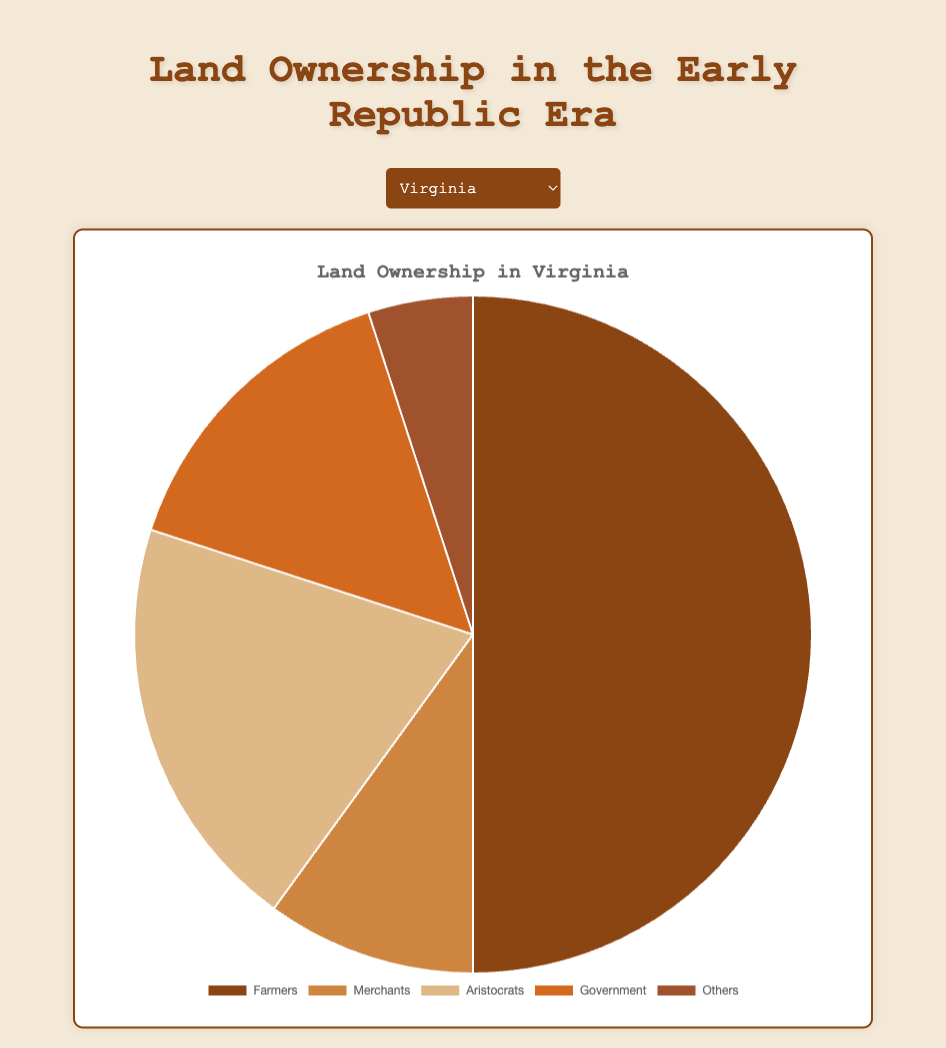What's the most significant category of land ownership in Virginia? Look at the pie chart for Virginia and identify the segment with the largest area. According to the data, Farmers own 50% of the land in Virginia, which is the largest category.
Answer: Farmers Compare the percentage of land owned by Merchants in New York and Pennsylvania. Which state has a higher percentage? Look at the pie charts for New York and Pennsylvania and compare the segments for Merchants. In New York, Merchants own 25% of the land, while in Pennsylvania, they own 20%. Thus, Merchants own a higher percentage of land in New York than in Pennsylvania.
Answer: New York Calculate the total percentage of land owned by Government and Others combined in Massachusetts. According to the pie chart for Massachusetts, the Government owns 25% of the land and Others own 10%. Add these percentages together: 25% + 10% = 35%.
Answer: 35% Which state has the least percentage of land owned by Aristocrats? Compare the Aristocrats' segments across the pie charts. In Massachusetts and Pennsylvania, Aristocrats own 10% of the land. This is the least percentage among all states listed. Massachusetts and Pennsylvania both have the least percentage of land owned by Aristocrats.
Answer: Massachusetts and Pennsylvania What is the difference in the percentage of land owned by Farmers between Virginia and North Carolina? Look at the pie charts for Virginia and North Carolina and compare the segments for Farmers. In Virginia, Farmers own 50% of the land, while in North Carolina, they own 55%. Subtract the smaller percentage from the larger one: 55% - 50% = 5%.
Answer: 5% 